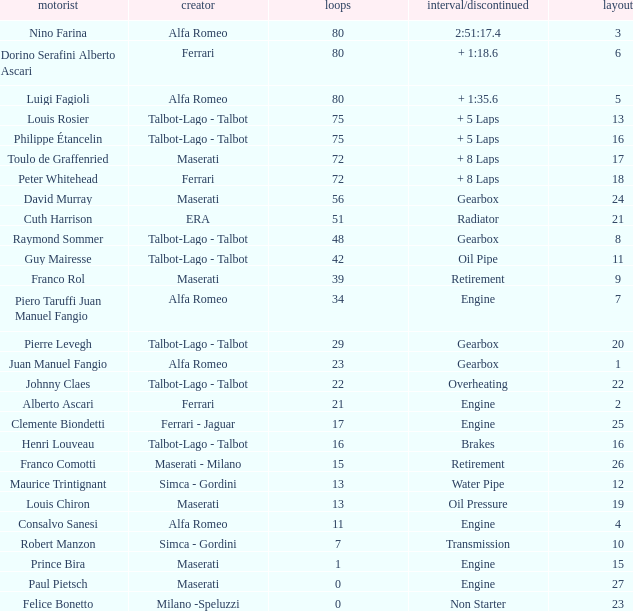When grid is less than 7, laps are greater than 17, and time/retired is + 1:35.6, who is the constructor? Alfa Romeo. 